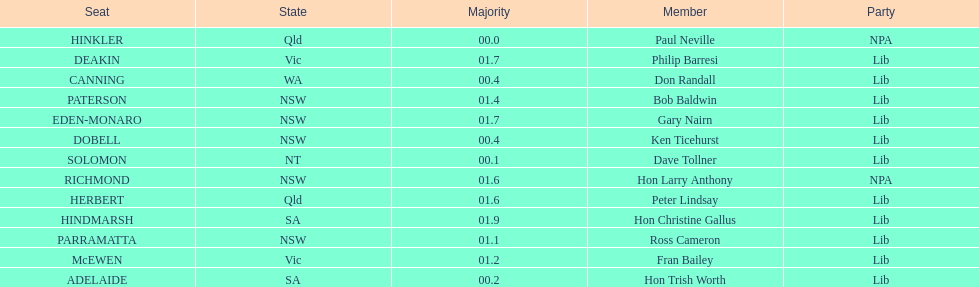Can you give me this table as a dict? {'header': ['Seat', 'State', 'Majority', 'Member', 'Party'], 'rows': [['HINKLER', 'Qld', '00.0', 'Paul Neville', 'NPA'], ['DEAKIN', 'Vic', '01.7', 'Philip Barresi', 'Lib'], ['CANNING', 'WA', '00.4', 'Don Randall', 'Lib'], ['PATERSON', 'NSW', '01.4', 'Bob Baldwin', 'Lib'], ['EDEN-MONARO', 'NSW', '01.7', 'Gary Nairn', 'Lib'], ['DOBELL', 'NSW', '00.4', 'Ken Ticehurst', 'Lib'], ['SOLOMON', 'NT', '00.1', 'Dave Tollner', 'Lib'], ['RICHMOND', 'NSW', '01.6', 'Hon Larry Anthony', 'NPA'], ['HERBERT', 'Qld', '01.6', 'Peter Lindsay', 'Lib'], ['HINDMARSH', 'SA', '01.9', 'Hon Christine Gallus', 'Lib'], ['PARRAMATTA', 'NSW', '01.1', 'Ross Cameron', 'Lib'], ['McEWEN', 'Vic', '01.2', 'Fran Bailey', 'Lib'], ['ADELAIDE', 'SA', '00.2', 'Hon Trish Worth', 'Lib']]} What is the difference in majority between hindmarsh and hinkler? 01.9. 